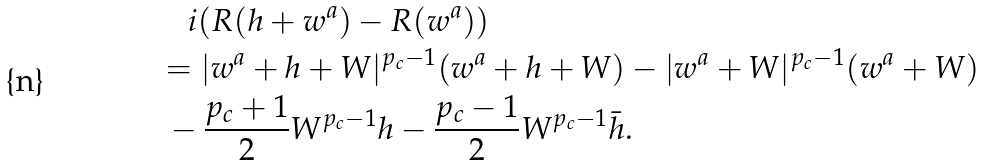Convert formula to latex. <formula><loc_0><loc_0><loc_500><loc_500>& \quad i ( R ( h + w ^ { a } ) - R ( w ^ { a } ) ) \\ & = | w ^ { a } + h + W | ^ { p _ { c } - 1 } ( w ^ { a } + h + W ) - | w ^ { a } + W | ^ { p _ { c } - 1 } ( w ^ { a } + W ) \\ & \ - \frac { p _ { c } + 1 } 2 W ^ { p _ { c } - 1 } h - \frac { p _ { c } - 1 } 2 W ^ { p _ { c } - 1 } \bar { h } .</formula> 